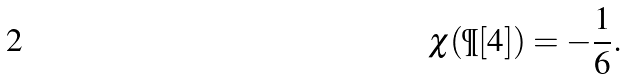Convert formula to latex. <formula><loc_0><loc_0><loc_500><loc_500>\chi ( \P [ 4 ] ) = - \frac { 1 } { 6 } .</formula> 